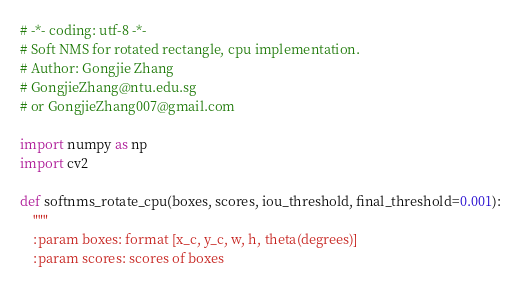<code> <loc_0><loc_0><loc_500><loc_500><_Python_># -*- coding: utf-8 -*-
# Soft NMS for rotated rectangle, cpu implementation.
# Author: Gongjie Zhang 
# GongjieZhang@ntu.edu.sg
# or GongjieZhang007@gmail.com

import numpy as np
import cv2

def softnms_rotate_cpu(boxes, scores, iou_threshold, final_threshold=0.001):
    """
    :param boxes: format [x_c, y_c, w, h, theta(degrees)]
    :param scores: scores of boxes</code> 